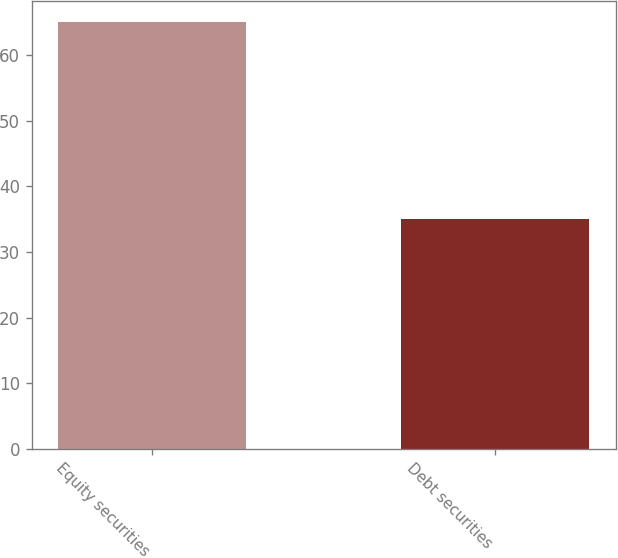Convert chart. <chart><loc_0><loc_0><loc_500><loc_500><bar_chart><fcel>Equity securities<fcel>Debt securities<nl><fcel>65<fcel>35<nl></chart> 